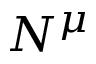<formula> <loc_0><loc_0><loc_500><loc_500>N ^ { \mu }</formula> 